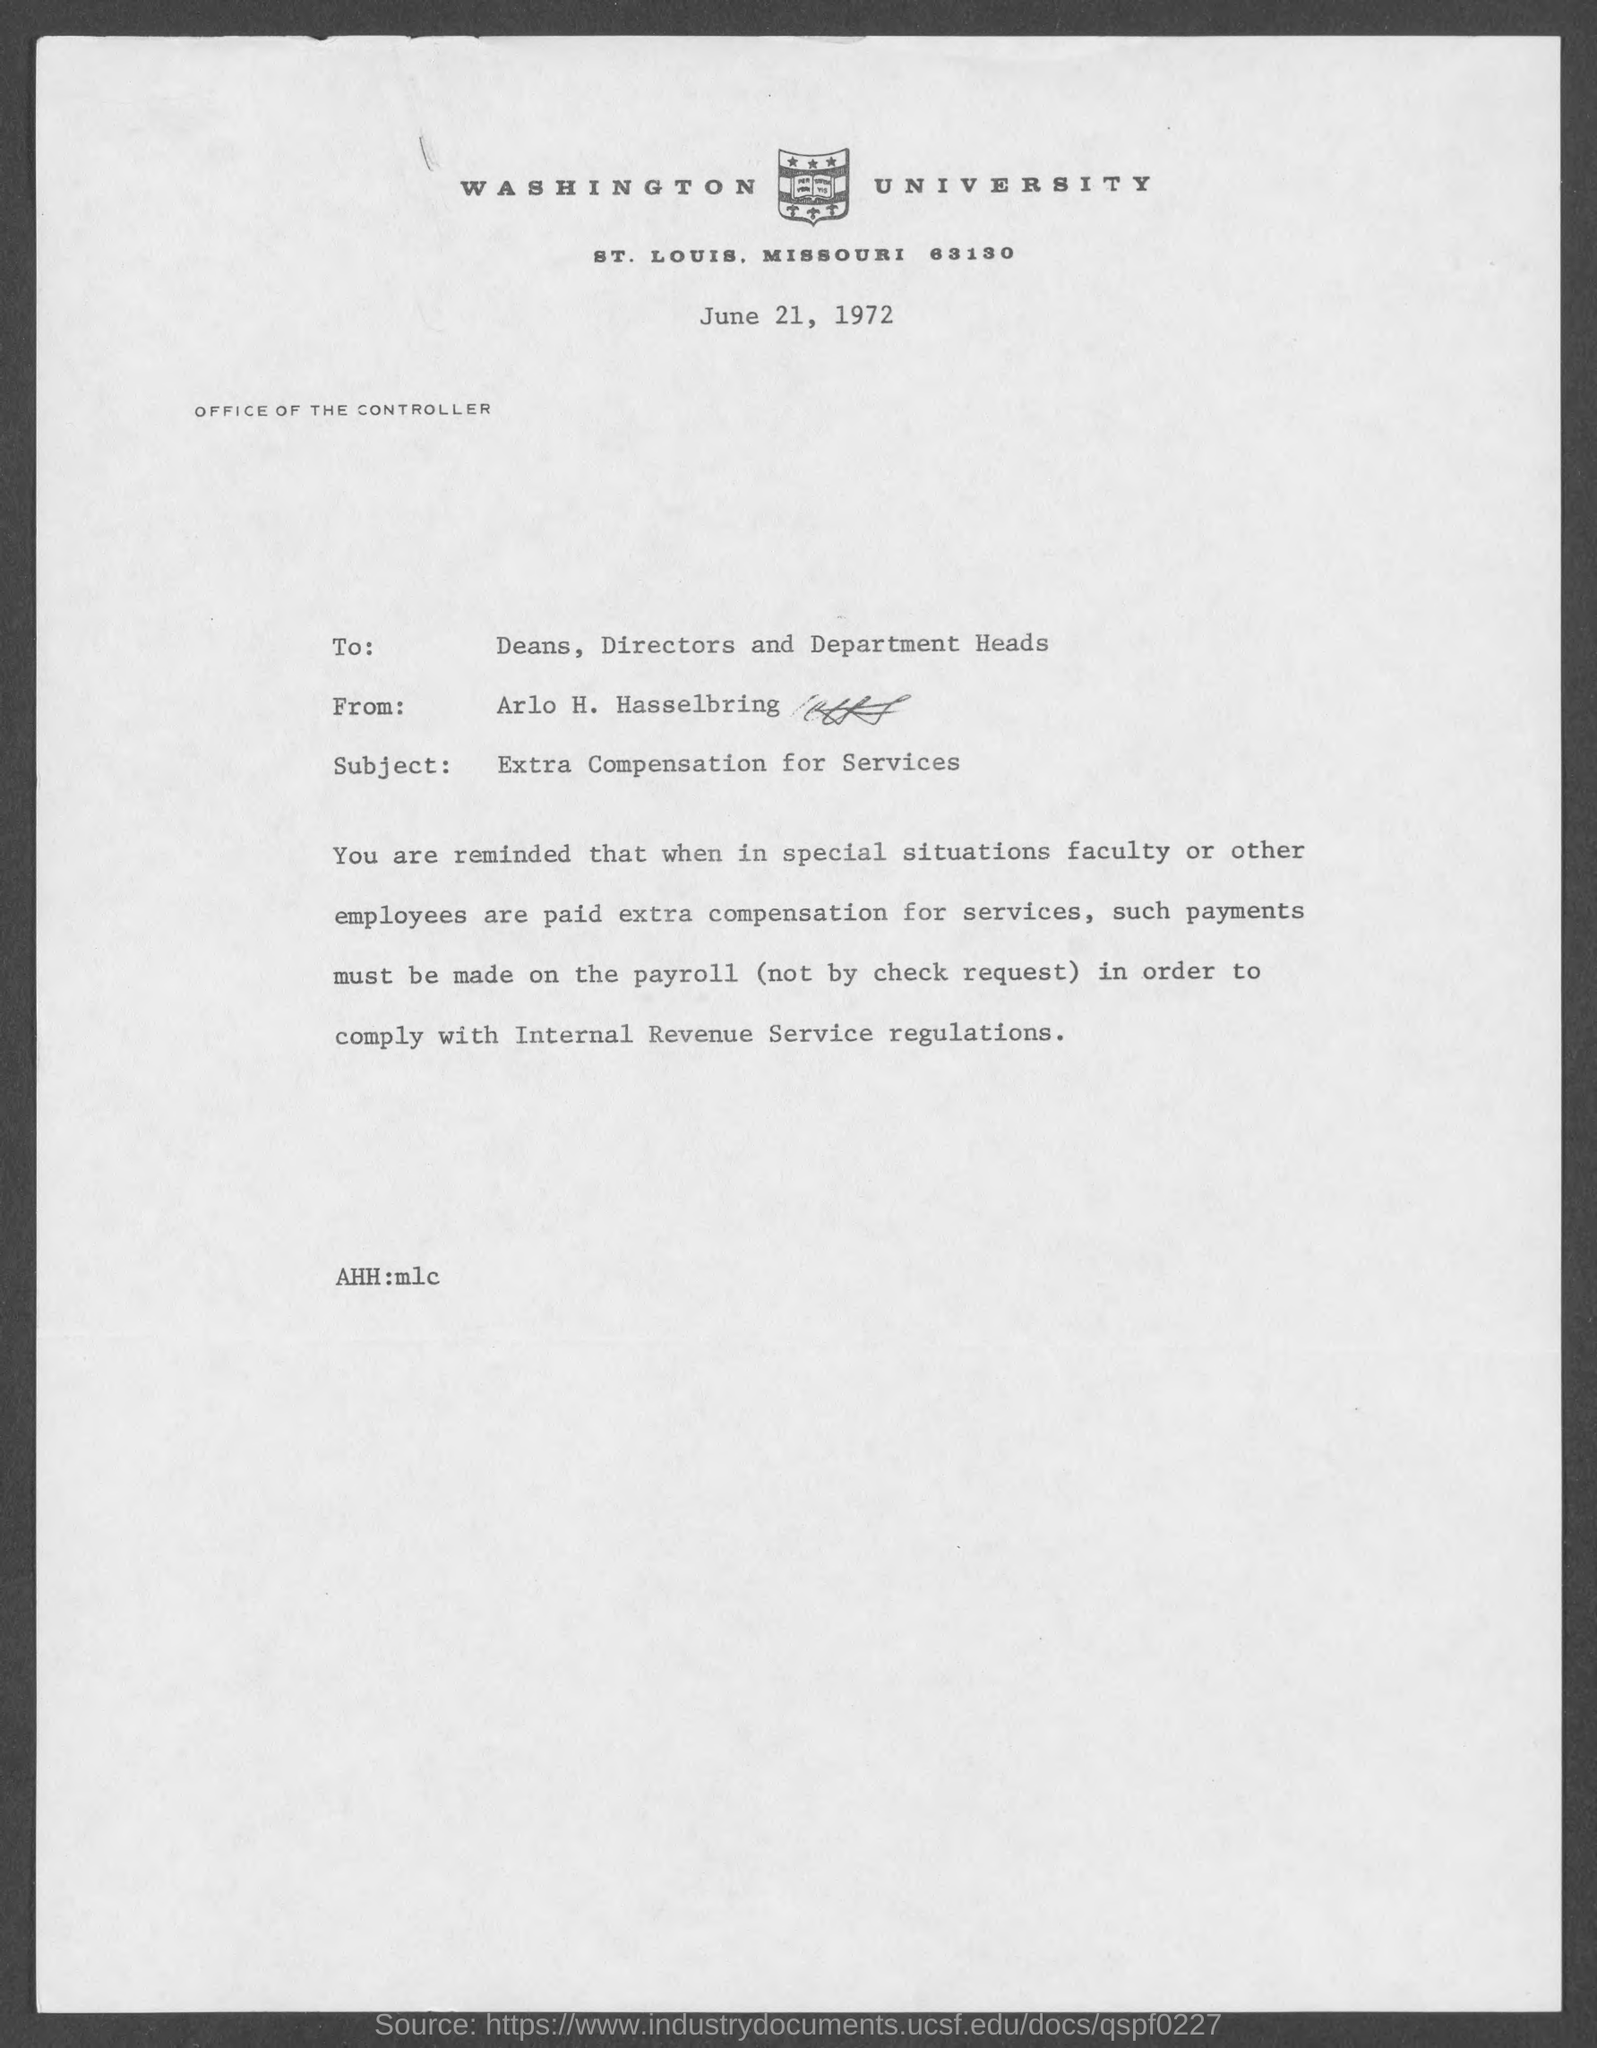Specify some key components in this picture. The letterhead mentions Washington University. The memo is addressed to Deans, Directors, and Department Heads. The date mentioned in the memo is June 21, 1972. The sender of this memo is Arlo H. Hasselbring. 